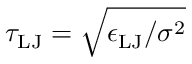<formula> <loc_0><loc_0><loc_500><loc_500>\tau _ { L J } = \sqrt { \epsilon _ { L J } / \sigma ^ { 2 } }</formula> 